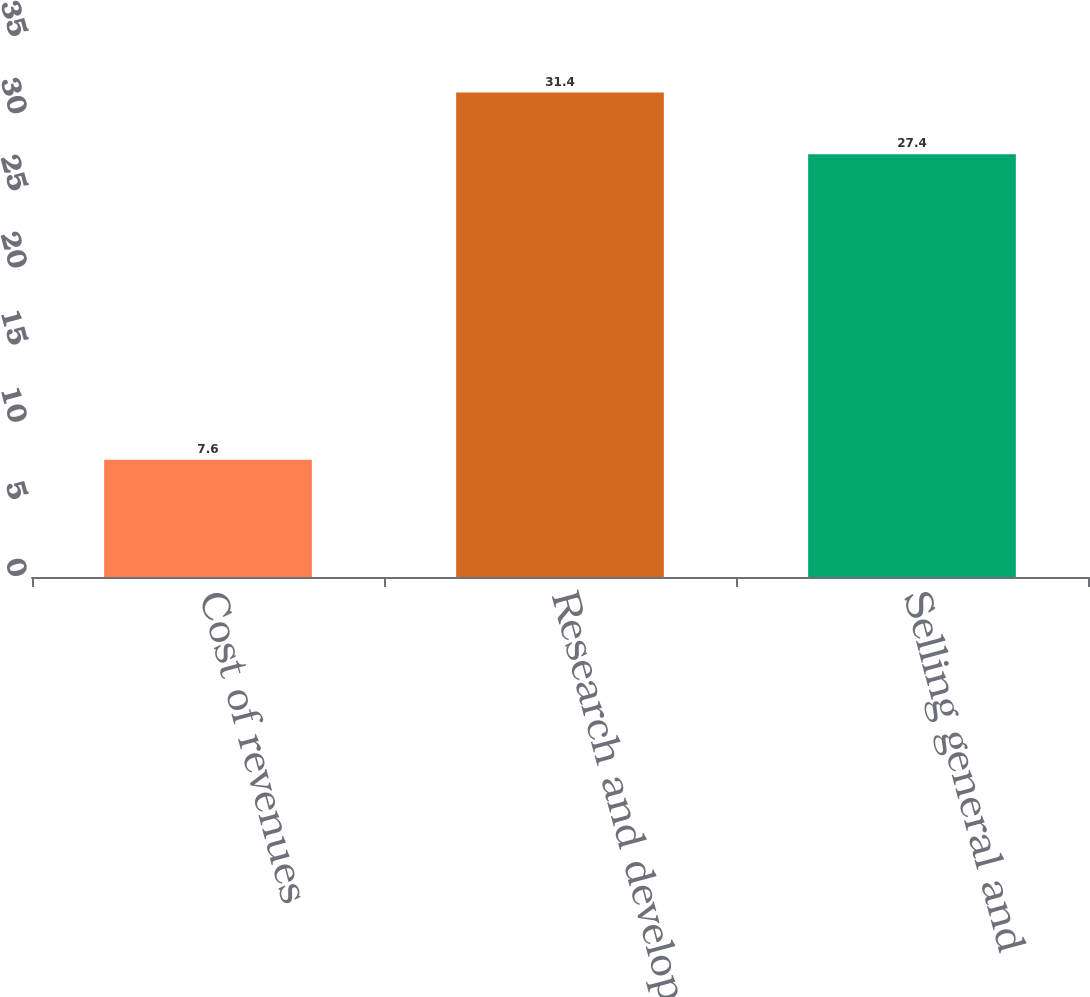Convert chart. <chart><loc_0><loc_0><loc_500><loc_500><bar_chart><fcel>Cost of revenues<fcel>Research and development<fcel>Selling general and<nl><fcel>7.6<fcel>31.4<fcel>27.4<nl></chart> 